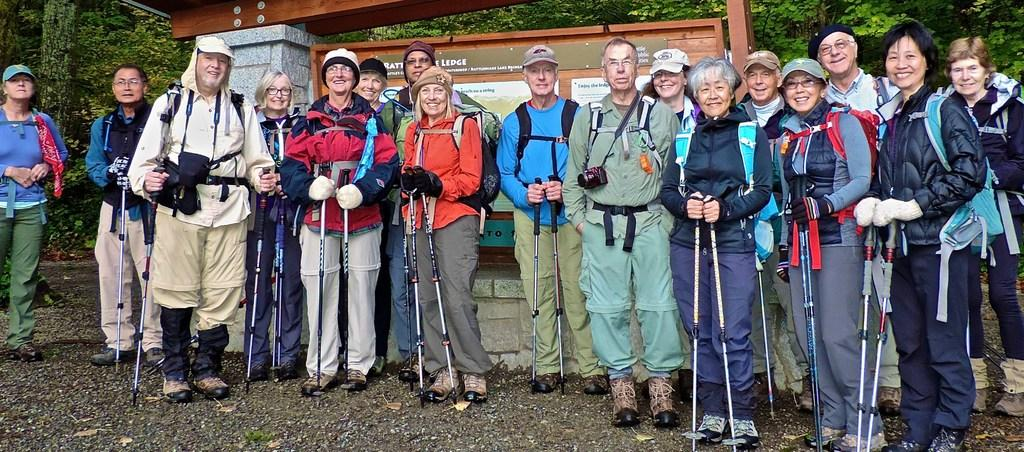What are the people in the image doing? The people in the image are standing in the middle of the image and holding sticks. What is the mood of the people in the image? The people in the image are smiling, which suggests a positive mood. What is located behind the people in the image? There is a banner behind the people in the image. What type of natural elements can be seen in the image? Trees are visible in the image. What type of key is being used to unlock the door in the image? There is no door or key present in the image; it features people standing with sticks and a banner in the background. 